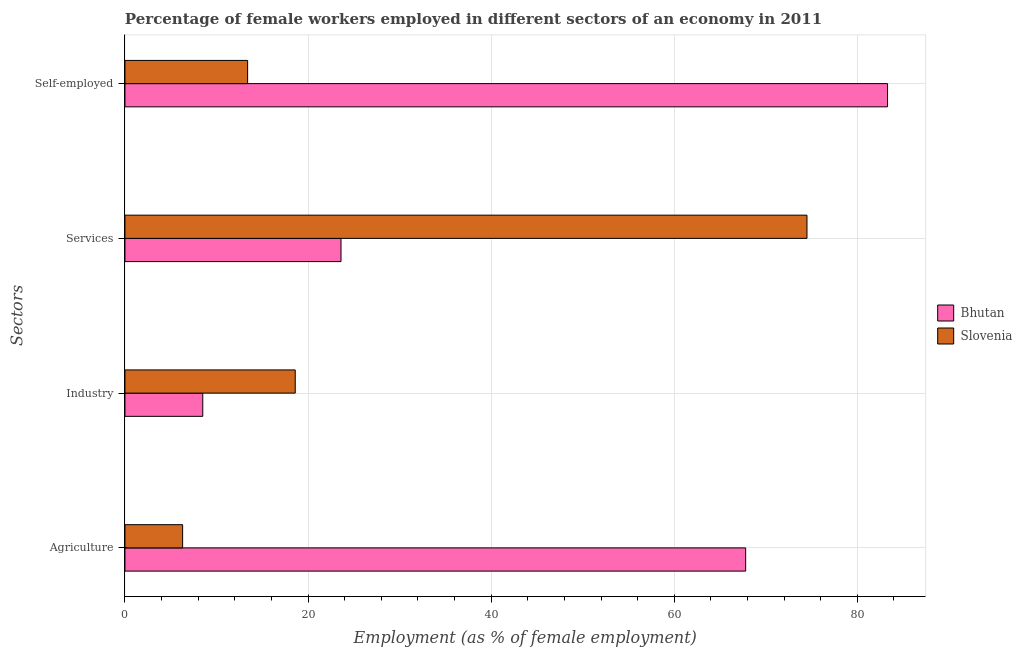How many different coloured bars are there?
Your answer should be compact. 2. Are the number of bars per tick equal to the number of legend labels?
Keep it short and to the point. Yes. Are the number of bars on each tick of the Y-axis equal?
Provide a succinct answer. Yes. How many bars are there on the 3rd tick from the bottom?
Your answer should be compact. 2. What is the label of the 4th group of bars from the top?
Keep it short and to the point. Agriculture. What is the percentage of self employed female workers in Slovenia?
Offer a terse response. 13.4. Across all countries, what is the maximum percentage of female workers in agriculture?
Ensure brevity in your answer.  67.8. Across all countries, what is the minimum percentage of female workers in industry?
Your response must be concise. 8.5. In which country was the percentage of female workers in industry maximum?
Your answer should be very brief. Slovenia. In which country was the percentage of female workers in industry minimum?
Offer a terse response. Bhutan. What is the total percentage of female workers in services in the graph?
Offer a terse response. 98.1. What is the difference between the percentage of self employed female workers in Slovenia and that in Bhutan?
Keep it short and to the point. -69.9. What is the difference between the percentage of female workers in agriculture in Bhutan and the percentage of female workers in services in Slovenia?
Give a very brief answer. -6.7. What is the average percentage of self employed female workers per country?
Offer a very short reply. 48.35. What is the difference between the percentage of female workers in services and percentage of self employed female workers in Bhutan?
Your response must be concise. -59.7. In how many countries, is the percentage of female workers in industry greater than 8 %?
Your answer should be compact. 2. What is the ratio of the percentage of female workers in industry in Slovenia to that in Bhutan?
Offer a very short reply. 2.19. What is the difference between the highest and the second highest percentage of self employed female workers?
Your answer should be very brief. 69.9. What is the difference between the highest and the lowest percentage of female workers in agriculture?
Your answer should be very brief. 61.5. Is it the case that in every country, the sum of the percentage of female workers in agriculture and percentage of self employed female workers is greater than the sum of percentage of female workers in industry and percentage of female workers in services?
Make the answer very short. No. What does the 1st bar from the top in Self-employed represents?
Your answer should be compact. Slovenia. What does the 1st bar from the bottom in Industry represents?
Provide a short and direct response. Bhutan. Are all the bars in the graph horizontal?
Provide a short and direct response. Yes. What is the difference between two consecutive major ticks on the X-axis?
Your answer should be compact. 20. Are the values on the major ticks of X-axis written in scientific E-notation?
Ensure brevity in your answer.  No. Where does the legend appear in the graph?
Provide a succinct answer. Center right. What is the title of the graph?
Your answer should be very brief. Percentage of female workers employed in different sectors of an economy in 2011. What is the label or title of the X-axis?
Ensure brevity in your answer.  Employment (as % of female employment). What is the label or title of the Y-axis?
Your answer should be very brief. Sectors. What is the Employment (as % of female employment) of Bhutan in Agriculture?
Offer a terse response. 67.8. What is the Employment (as % of female employment) in Slovenia in Agriculture?
Provide a succinct answer. 6.3. What is the Employment (as % of female employment) of Slovenia in Industry?
Offer a terse response. 18.6. What is the Employment (as % of female employment) in Bhutan in Services?
Your response must be concise. 23.6. What is the Employment (as % of female employment) in Slovenia in Services?
Make the answer very short. 74.5. What is the Employment (as % of female employment) in Bhutan in Self-employed?
Your response must be concise. 83.3. What is the Employment (as % of female employment) of Slovenia in Self-employed?
Your answer should be very brief. 13.4. Across all Sectors, what is the maximum Employment (as % of female employment) in Bhutan?
Offer a terse response. 83.3. Across all Sectors, what is the maximum Employment (as % of female employment) in Slovenia?
Offer a terse response. 74.5. Across all Sectors, what is the minimum Employment (as % of female employment) of Bhutan?
Provide a succinct answer. 8.5. Across all Sectors, what is the minimum Employment (as % of female employment) in Slovenia?
Provide a short and direct response. 6.3. What is the total Employment (as % of female employment) of Bhutan in the graph?
Keep it short and to the point. 183.2. What is the total Employment (as % of female employment) of Slovenia in the graph?
Provide a short and direct response. 112.8. What is the difference between the Employment (as % of female employment) in Bhutan in Agriculture and that in Industry?
Keep it short and to the point. 59.3. What is the difference between the Employment (as % of female employment) in Bhutan in Agriculture and that in Services?
Make the answer very short. 44.2. What is the difference between the Employment (as % of female employment) in Slovenia in Agriculture and that in Services?
Your response must be concise. -68.2. What is the difference between the Employment (as % of female employment) of Bhutan in Agriculture and that in Self-employed?
Offer a very short reply. -15.5. What is the difference between the Employment (as % of female employment) of Slovenia in Agriculture and that in Self-employed?
Ensure brevity in your answer.  -7.1. What is the difference between the Employment (as % of female employment) in Bhutan in Industry and that in Services?
Your response must be concise. -15.1. What is the difference between the Employment (as % of female employment) in Slovenia in Industry and that in Services?
Your answer should be compact. -55.9. What is the difference between the Employment (as % of female employment) in Bhutan in Industry and that in Self-employed?
Your response must be concise. -74.8. What is the difference between the Employment (as % of female employment) in Bhutan in Services and that in Self-employed?
Provide a short and direct response. -59.7. What is the difference between the Employment (as % of female employment) in Slovenia in Services and that in Self-employed?
Offer a terse response. 61.1. What is the difference between the Employment (as % of female employment) in Bhutan in Agriculture and the Employment (as % of female employment) in Slovenia in Industry?
Ensure brevity in your answer.  49.2. What is the difference between the Employment (as % of female employment) of Bhutan in Agriculture and the Employment (as % of female employment) of Slovenia in Services?
Offer a terse response. -6.7. What is the difference between the Employment (as % of female employment) in Bhutan in Agriculture and the Employment (as % of female employment) in Slovenia in Self-employed?
Offer a terse response. 54.4. What is the difference between the Employment (as % of female employment) of Bhutan in Industry and the Employment (as % of female employment) of Slovenia in Services?
Offer a terse response. -66. What is the average Employment (as % of female employment) in Bhutan per Sectors?
Offer a terse response. 45.8. What is the average Employment (as % of female employment) in Slovenia per Sectors?
Give a very brief answer. 28.2. What is the difference between the Employment (as % of female employment) of Bhutan and Employment (as % of female employment) of Slovenia in Agriculture?
Keep it short and to the point. 61.5. What is the difference between the Employment (as % of female employment) in Bhutan and Employment (as % of female employment) in Slovenia in Services?
Offer a terse response. -50.9. What is the difference between the Employment (as % of female employment) in Bhutan and Employment (as % of female employment) in Slovenia in Self-employed?
Provide a succinct answer. 69.9. What is the ratio of the Employment (as % of female employment) of Bhutan in Agriculture to that in Industry?
Provide a short and direct response. 7.98. What is the ratio of the Employment (as % of female employment) of Slovenia in Agriculture to that in Industry?
Provide a succinct answer. 0.34. What is the ratio of the Employment (as % of female employment) in Bhutan in Agriculture to that in Services?
Provide a short and direct response. 2.87. What is the ratio of the Employment (as % of female employment) of Slovenia in Agriculture to that in Services?
Ensure brevity in your answer.  0.08. What is the ratio of the Employment (as % of female employment) in Bhutan in Agriculture to that in Self-employed?
Offer a terse response. 0.81. What is the ratio of the Employment (as % of female employment) in Slovenia in Agriculture to that in Self-employed?
Offer a very short reply. 0.47. What is the ratio of the Employment (as % of female employment) in Bhutan in Industry to that in Services?
Offer a terse response. 0.36. What is the ratio of the Employment (as % of female employment) of Slovenia in Industry to that in Services?
Your response must be concise. 0.25. What is the ratio of the Employment (as % of female employment) of Bhutan in Industry to that in Self-employed?
Provide a succinct answer. 0.1. What is the ratio of the Employment (as % of female employment) of Slovenia in Industry to that in Self-employed?
Make the answer very short. 1.39. What is the ratio of the Employment (as % of female employment) in Bhutan in Services to that in Self-employed?
Your answer should be very brief. 0.28. What is the ratio of the Employment (as % of female employment) in Slovenia in Services to that in Self-employed?
Provide a succinct answer. 5.56. What is the difference between the highest and the second highest Employment (as % of female employment) of Bhutan?
Make the answer very short. 15.5. What is the difference between the highest and the second highest Employment (as % of female employment) in Slovenia?
Your response must be concise. 55.9. What is the difference between the highest and the lowest Employment (as % of female employment) in Bhutan?
Offer a very short reply. 74.8. What is the difference between the highest and the lowest Employment (as % of female employment) in Slovenia?
Provide a short and direct response. 68.2. 